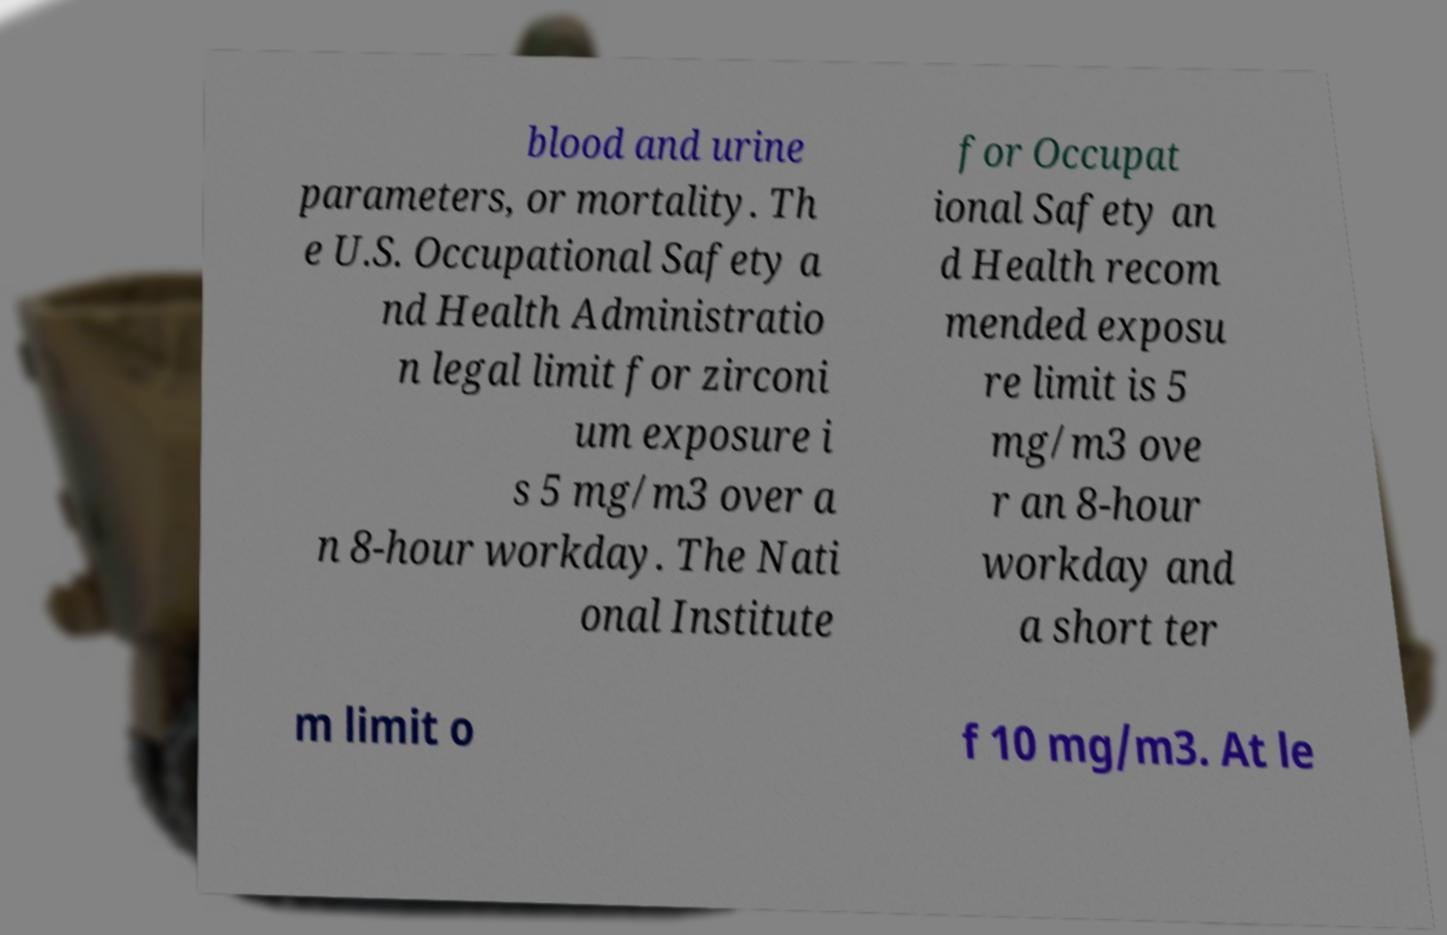Can you read and provide the text displayed in the image?This photo seems to have some interesting text. Can you extract and type it out for me? blood and urine parameters, or mortality. Th e U.S. Occupational Safety a nd Health Administratio n legal limit for zirconi um exposure i s 5 mg/m3 over a n 8-hour workday. The Nati onal Institute for Occupat ional Safety an d Health recom mended exposu re limit is 5 mg/m3 ove r an 8-hour workday and a short ter m limit o f 10 mg/m3. At le 